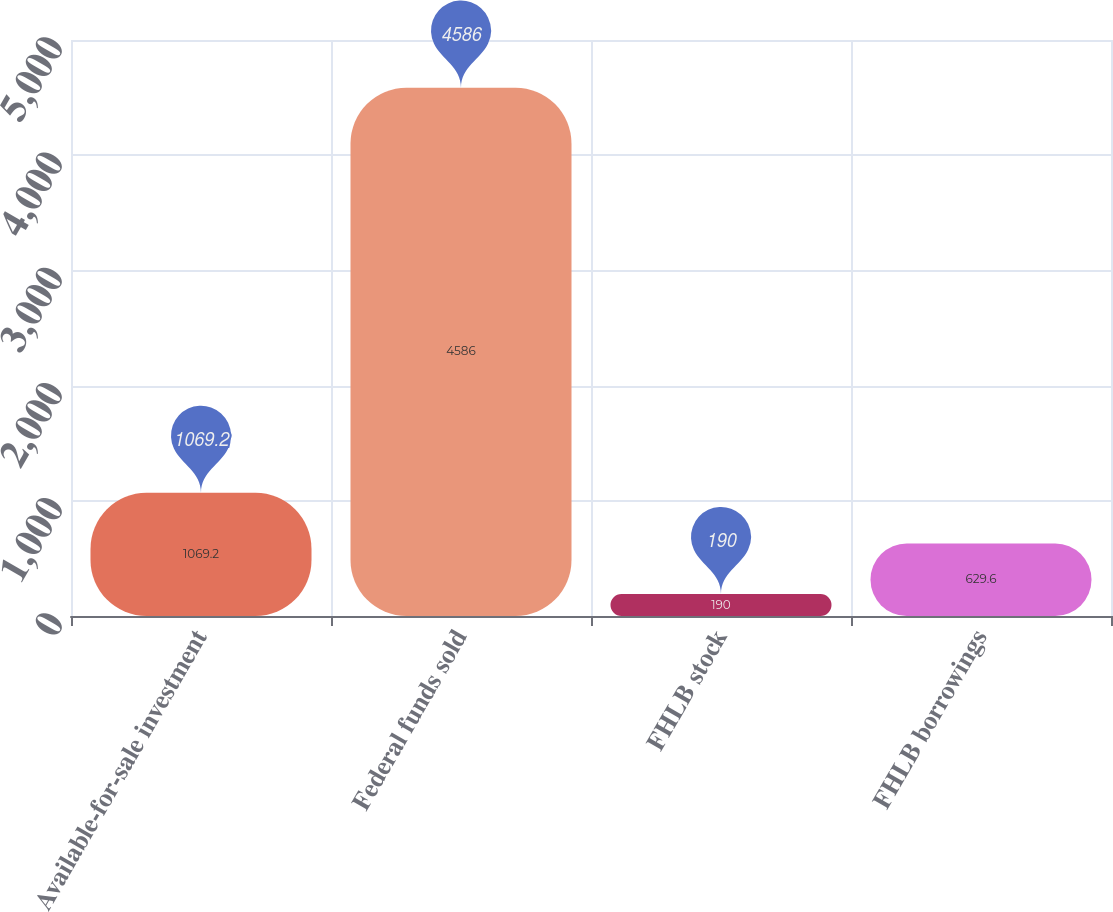Convert chart. <chart><loc_0><loc_0><loc_500><loc_500><bar_chart><fcel>Available-for-sale investment<fcel>Federal funds sold<fcel>FHLB stock<fcel>FHLB borrowings<nl><fcel>1069.2<fcel>4586<fcel>190<fcel>629.6<nl></chart> 